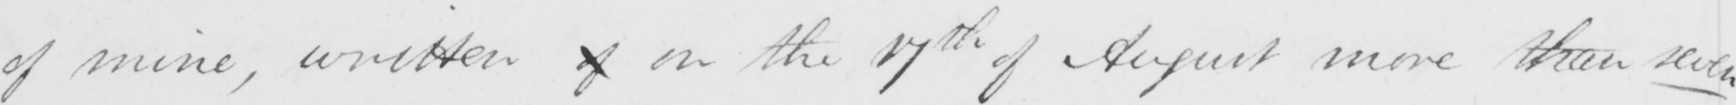What is written in this line of handwriting? of mine , written of on the 17th of August more than seven 